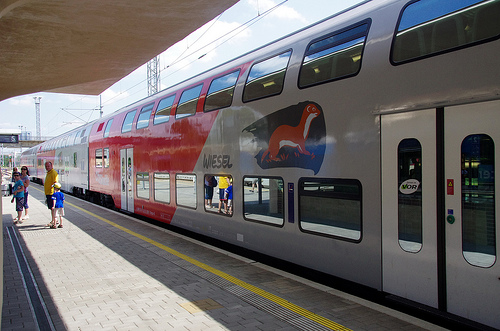Please provide a short description for this region: [0.75, 0.37, 1.0, 0.79]. This region effectively captures the doors of a train. Each door is well-defined and positioned for passenger boarding. 